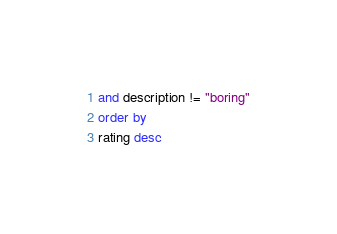<code> <loc_0><loc_0><loc_500><loc_500><_SQL_>and description != "boring"
order by
rating desc</code> 